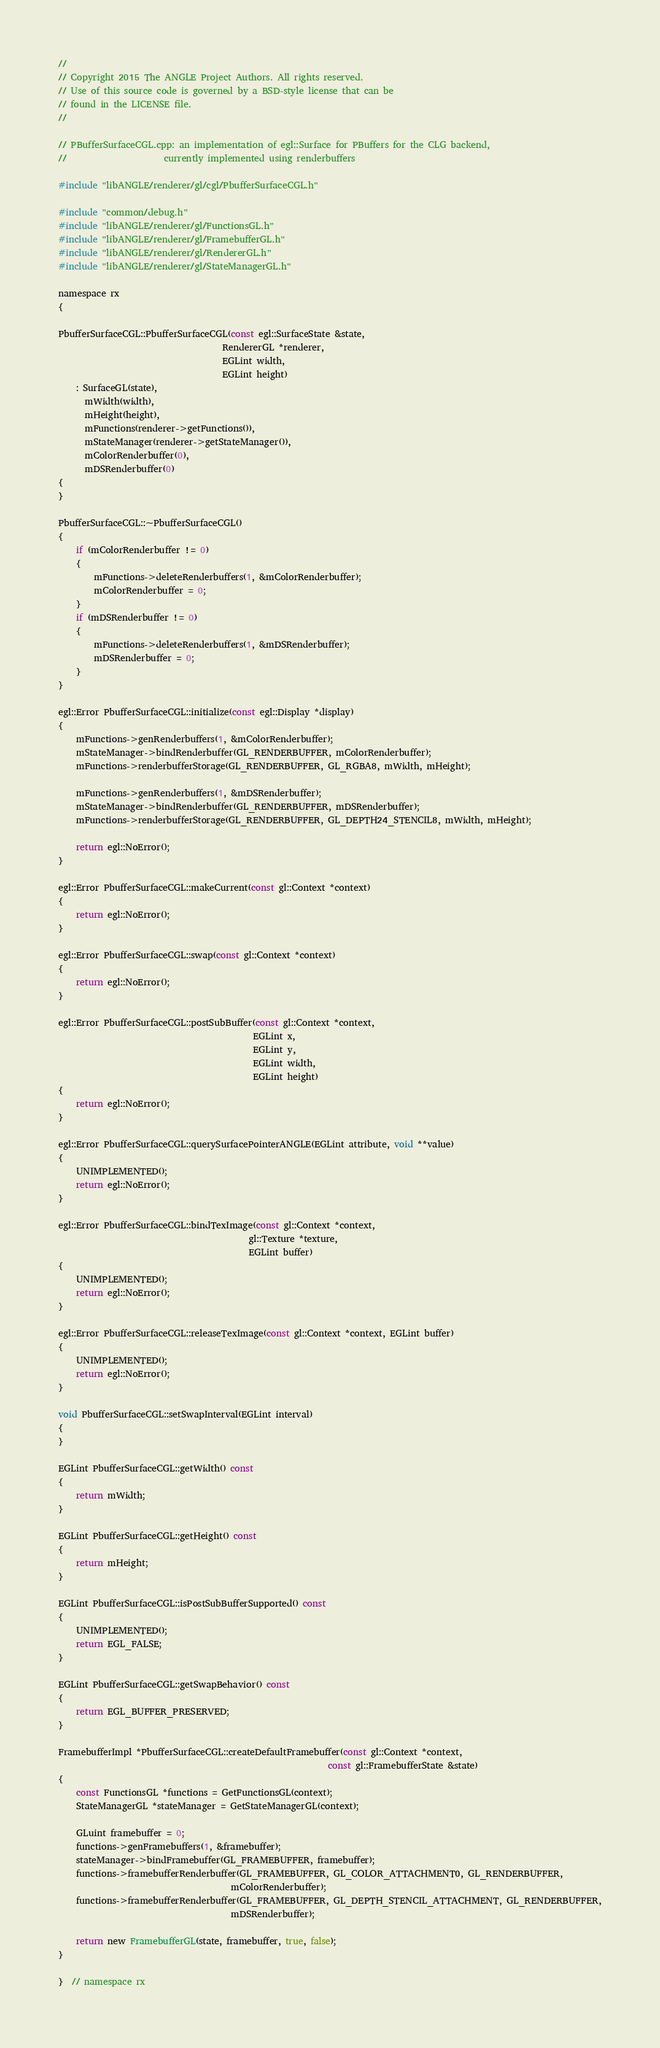<code> <loc_0><loc_0><loc_500><loc_500><_ObjectiveC_>//
// Copyright 2015 The ANGLE Project Authors. All rights reserved.
// Use of this source code is governed by a BSD-style license that can be
// found in the LICENSE file.
//

// PBufferSurfaceCGL.cpp: an implementation of egl::Surface for PBuffers for the CLG backend,
//                      currently implemented using renderbuffers

#include "libANGLE/renderer/gl/cgl/PbufferSurfaceCGL.h"

#include "common/debug.h"
#include "libANGLE/renderer/gl/FunctionsGL.h"
#include "libANGLE/renderer/gl/FramebufferGL.h"
#include "libANGLE/renderer/gl/RendererGL.h"
#include "libANGLE/renderer/gl/StateManagerGL.h"

namespace rx
{

PbufferSurfaceCGL::PbufferSurfaceCGL(const egl::SurfaceState &state,
                                     RendererGL *renderer,
                                     EGLint width,
                                     EGLint height)
    : SurfaceGL(state),
      mWidth(width),
      mHeight(height),
      mFunctions(renderer->getFunctions()),
      mStateManager(renderer->getStateManager()),
      mColorRenderbuffer(0),
      mDSRenderbuffer(0)
{
}

PbufferSurfaceCGL::~PbufferSurfaceCGL()
{
    if (mColorRenderbuffer != 0)
    {
        mFunctions->deleteRenderbuffers(1, &mColorRenderbuffer);
        mColorRenderbuffer = 0;
    }
    if (mDSRenderbuffer != 0)
    {
        mFunctions->deleteRenderbuffers(1, &mDSRenderbuffer);
        mDSRenderbuffer = 0;
    }
}

egl::Error PbufferSurfaceCGL::initialize(const egl::Display *display)
{
    mFunctions->genRenderbuffers(1, &mColorRenderbuffer);
    mStateManager->bindRenderbuffer(GL_RENDERBUFFER, mColorRenderbuffer);
    mFunctions->renderbufferStorage(GL_RENDERBUFFER, GL_RGBA8, mWidth, mHeight);

    mFunctions->genRenderbuffers(1, &mDSRenderbuffer);
    mStateManager->bindRenderbuffer(GL_RENDERBUFFER, mDSRenderbuffer);
    mFunctions->renderbufferStorage(GL_RENDERBUFFER, GL_DEPTH24_STENCIL8, mWidth, mHeight);

    return egl::NoError();
}

egl::Error PbufferSurfaceCGL::makeCurrent(const gl::Context *context)
{
    return egl::NoError();
}

egl::Error PbufferSurfaceCGL::swap(const gl::Context *context)
{
    return egl::NoError();
}

egl::Error PbufferSurfaceCGL::postSubBuffer(const gl::Context *context,
                                            EGLint x,
                                            EGLint y,
                                            EGLint width,
                                            EGLint height)
{
    return egl::NoError();
}

egl::Error PbufferSurfaceCGL::querySurfacePointerANGLE(EGLint attribute, void **value)
{
    UNIMPLEMENTED();
    return egl::NoError();
}

egl::Error PbufferSurfaceCGL::bindTexImage(const gl::Context *context,
                                           gl::Texture *texture,
                                           EGLint buffer)
{
    UNIMPLEMENTED();
    return egl::NoError();
}

egl::Error PbufferSurfaceCGL::releaseTexImage(const gl::Context *context, EGLint buffer)
{
    UNIMPLEMENTED();
    return egl::NoError();
}

void PbufferSurfaceCGL::setSwapInterval(EGLint interval)
{
}

EGLint PbufferSurfaceCGL::getWidth() const
{
    return mWidth;
}

EGLint PbufferSurfaceCGL::getHeight() const
{
    return mHeight;
}

EGLint PbufferSurfaceCGL::isPostSubBufferSupported() const
{
    UNIMPLEMENTED();
    return EGL_FALSE;
}

EGLint PbufferSurfaceCGL::getSwapBehavior() const
{
    return EGL_BUFFER_PRESERVED;
}

FramebufferImpl *PbufferSurfaceCGL::createDefaultFramebuffer(const gl::Context *context,
                                                             const gl::FramebufferState &state)
{
    const FunctionsGL *functions = GetFunctionsGL(context);
    StateManagerGL *stateManager = GetStateManagerGL(context);

    GLuint framebuffer = 0;
    functions->genFramebuffers(1, &framebuffer);
    stateManager->bindFramebuffer(GL_FRAMEBUFFER, framebuffer);
    functions->framebufferRenderbuffer(GL_FRAMEBUFFER, GL_COLOR_ATTACHMENT0, GL_RENDERBUFFER,
                                       mColorRenderbuffer);
    functions->framebufferRenderbuffer(GL_FRAMEBUFFER, GL_DEPTH_STENCIL_ATTACHMENT, GL_RENDERBUFFER,
                                       mDSRenderbuffer);

    return new FramebufferGL(state, framebuffer, true, false);
}

}  // namespace rx
</code> 